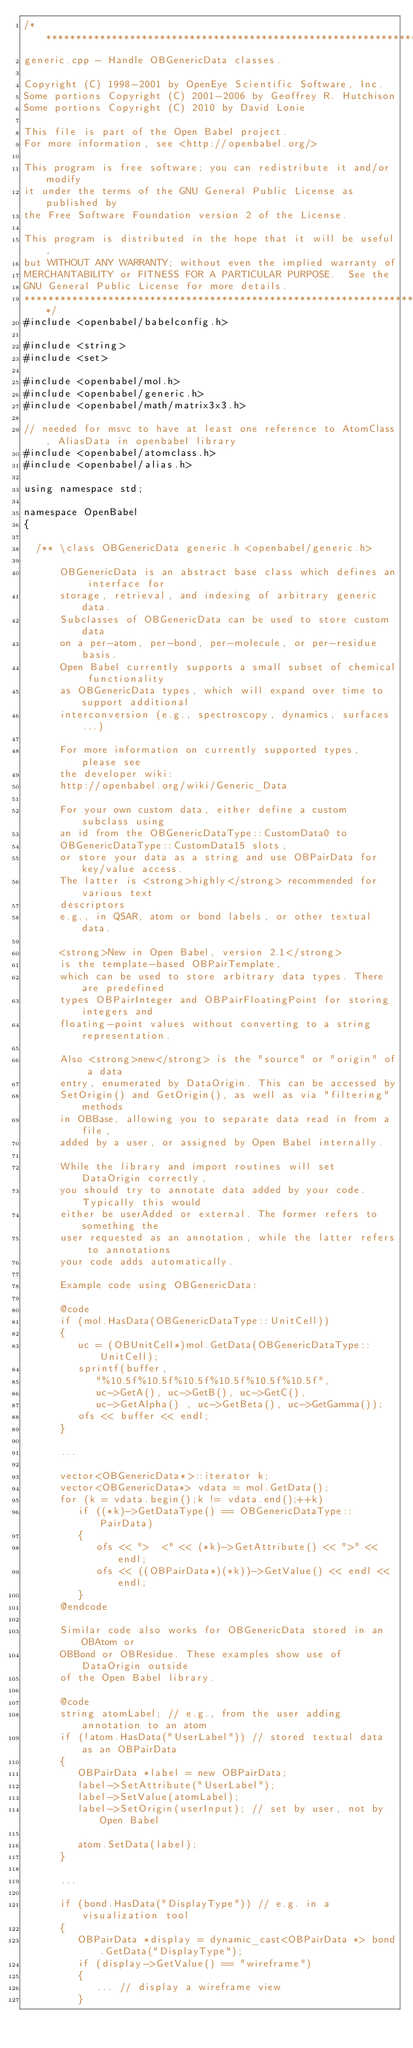<code> <loc_0><loc_0><loc_500><loc_500><_C++_>/**********************************************************************
generic.cpp - Handle OBGenericData classes.

Copyright (C) 1998-2001 by OpenEye Scientific Software, Inc.
Some portions Copyright (C) 2001-2006 by Geoffrey R. Hutchison
Some portions Copyright (C) 2010 by David Lonie

This file is part of the Open Babel project.
For more information, see <http://openbabel.org/>

This program is free software; you can redistribute it and/or modify
it under the terms of the GNU General Public License as published by
the Free Software Foundation version 2 of the License.

This program is distributed in the hope that it will be useful,
but WITHOUT ANY WARRANTY; without even the implied warranty of
MERCHANTABILITY or FITNESS FOR A PARTICULAR PURPOSE.  See the
GNU General Public License for more details.
***********************************************************************/
#include <openbabel/babelconfig.h>

#include <string>
#include <set>

#include <openbabel/mol.h>
#include <openbabel/generic.h>
#include <openbabel/math/matrix3x3.h>

// needed for msvc to have at least one reference to AtomClass, AliasData in openbabel library
#include <openbabel/atomclass.h>
#include <openbabel/alias.h>

using namespace std;

namespace OpenBabel
{

  /** \class OBGenericData generic.h <openbabel/generic.h>

      OBGenericData is an abstract base class which defines an interface for
      storage, retrieval, and indexing of arbitrary generic data.
      Subclasses of OBGenericData can be used to store custom data
      on a per-atom, per-bond, per-molecule, or per-residue basis.
      Open Babel currently supports a small subset of chemical functionality
      as OBGenericData types, which will expand over time to support additional
      interconversion (e.g., spectroscopy, dynamics, surfaces...)

      For more information on currently supported types, please see
      the developer wiki:
      http://openbabel.org/wiki/Generic_Data

      For your own custom data, either define a custom subclass using
      an id from the OBGenericDataType::CustomData0 to
      OBGenericDataType::CustomData15 slots,
      or store your data as a string and use OBPairData for key/value access.
      The latter is <strong>highly</strong> recommended for various text
      descriptors
      e.g., in QSAR, atom or bond labels, or other textual data.

      <strong>New in Open Babel, version 2.1</strong>
      is the template-based OBPairTemplate,
      which can be used to store arbitrary data types. There are predefined
      types OBPairInteger and OBPairFloatingPoint for storing integers and
      floating-point values without converting to a string representation.

      Also <strong>new</strong> is the "source" or "origin" of a data
      entry, enumerated by DataOrigin. This can be accessed by
      SetOrigin() and GetOrigin(), as well as via "filtering" methods
      in OBBase, allowing you to separate data read in from a file,
      added by a user, or assigned by Open Babel internally.

      While the library and import routines will set DataOrigin correctly,
      you should try to annotate data added by your code. Typically this would
      either be userAdded or external. The former refers to something the
      user requested as an annotation, while the latter refers to annotations
      your code adds automatically.

      Example code using OBGenericData:

      @code
      if (mol.HasData(OBGenericDataType::UnitCell))
      {
         uc = (OBUnitCell*)mol.GetData(OBGenericDataType::UnitCell);
         sprintf(buffer,
            "%10.5f%10.5f%10.5f%10.5f%10.5f%10.5f",
            uc->GetA(), uc->GetB(), uc->GetC(),
            uc->GetAlpha() , uc->GetBeta(), uc->GetGamma());
         ofs << buffer << endl;
      }

      ...

      vector<OBGenericData*>::iterator k;
      vector<OBGenericData*> vdata = mol.GetData();
      for (k = vdata.begin();k != vdata.end();++k)
         if ((*k)->GetDataType() == OBGenericDataType::PairData)
         {
            ofs << ">  <" << (*k)->GetAttribute() << ">" << endl;
            ofs << ((OBPairData*)(*k))->GetValue() << endl << endl;
         }
      @endcode

      Similar code also works for OBGenericData stored in an OBAtom or
      OBBond or OBResidue. These examples show use of DataOrigin outside
      of the Open Babel library.

      @code
      string atomLabel; // e.g., from the user adding annotation to an atom
      if (!atom.HasData("UserLabel")) // stored textual data as an OBPairData
      {
         OBPairData *label = new OBPairData;
         label->SetAttribute("UserLabel");
         label->SetValue(atomLabel);
         label->SetOrigin(userInput); // set by user, not by Open Babel

         atom.SetData(label);
      }

      ...

      if (bond.HasData("DisplayType")) // e.g. in a visualization tool
      {
         OBPairData *display = dynamic_cast<OBPairData *> bond.GetData("DisplayType");
         if (display->GetValue() == "wireframe")
         {
            ... // display a wireframe view
         }</code> 